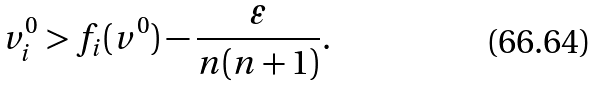<formula> <loc_0><loc_0><loc_500><loc_500>v ^ { 0 } _ { i } > f _ { i } ( v ^ { 0 } ) - \frac { \varepsilon } { n ( n + 1 ) } .</formula> 